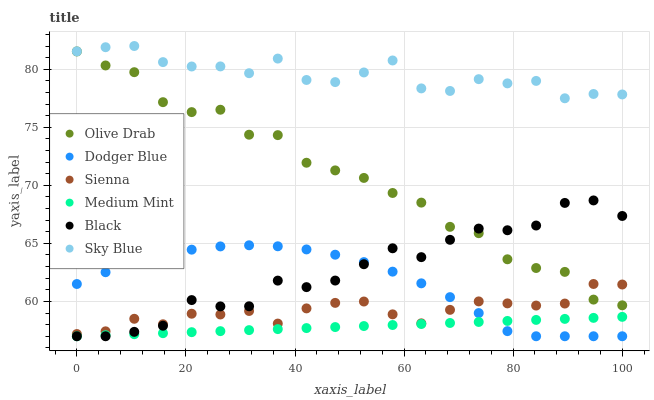Does Medium Mint have the minimum area under the curve?
Answer yes or no. Yes. Does Sky Blue have the maximum area under the curve?
Answer yes or no. Yes. Does Sienna have the minimum area under the curve?
Answer yes or no. No. Does Sienna have the maximum area under the curve?
Answer yes or no. No. Is Medium Mint the smoothest?
Answer yes or no. Yes. Is Olive Drab the roughest?
Answer yes or no. Yes. Is Sienna the smoothest?
Answer yes or no. No. Is Sienna the roughest?
Answer yes or no. No. Does Medium Mint have the lowest value?
Answer yes or no. Yes. Does Sienna have the lowest value?
Answer yes or no. No. Does Sky Blue have the highest value?
Answer yes or no. Yes. Does Sienna have the highest value?
Answer yes or no. No. Is Medium Mint less than Sky Blue?
Answer yes or no. Yes. Is Sky Blue greater than Medium Mint?
Answer yes or no. Yes. Does Black intersect Olive Drab?
Answer yes or no. Yes. Is Black less than Olive Drab?
Answer yes or no. No. Is Black greater than Olive Drab?
Answer yes or no. No. Does Medium Mint intersect Sky Blue?
Answer yes or no. No. 